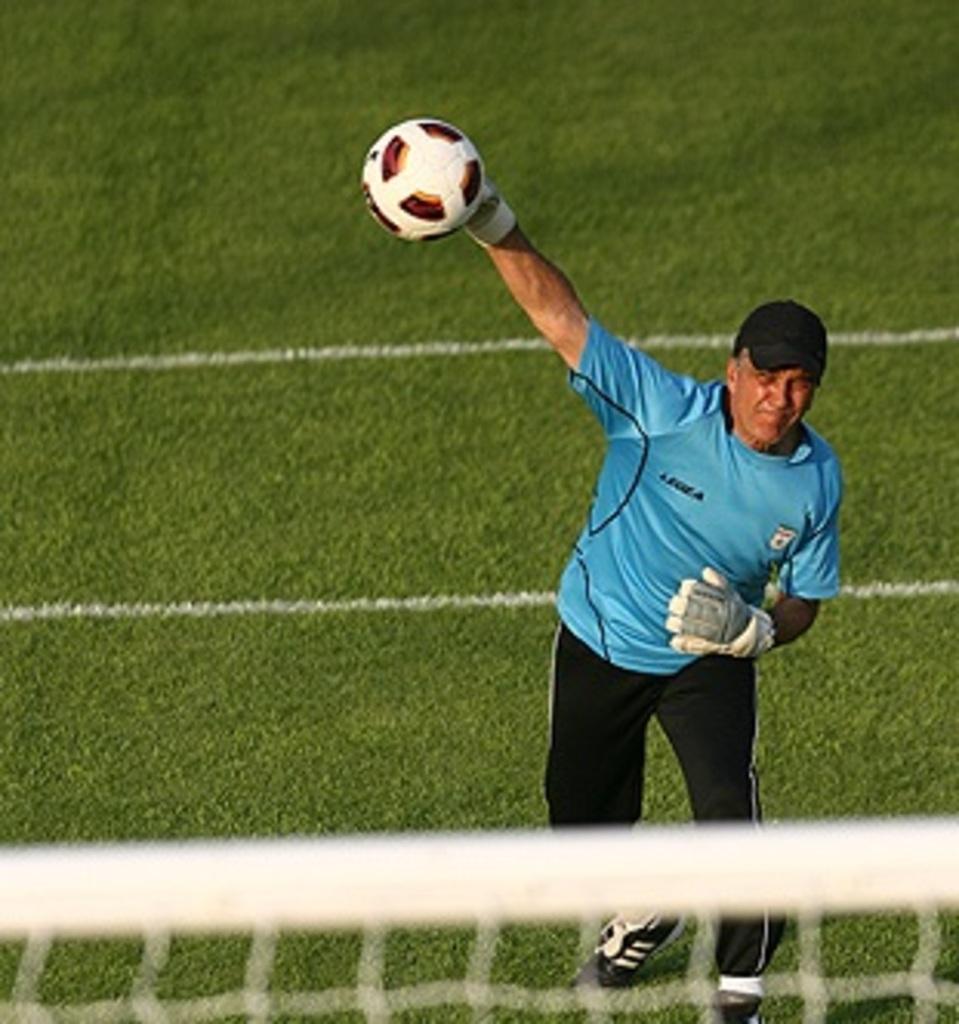How would you summarize this image in a sentence or two? In this image I can see a man is throwing the ball, he wore blue color t-shirt, black color trouser, shoes. At the bottom it is the net, this is the grass. 